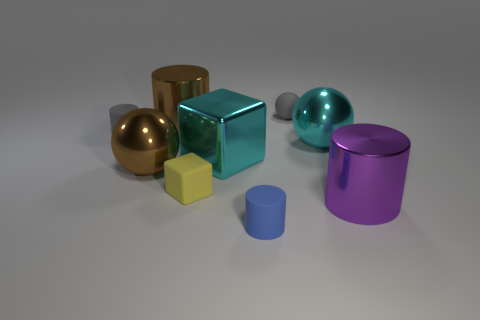Subtract all big metal spheres. How many spheres are left? 1 Add 1 red rubber things. How many objects exist? 10 Subtract all brown spheres. How many spheres are left? 2 Subtract all spheres. How many objects are left? 6 Subtract 1 cylinders. How many cylinders are left? 3 Subtract all purple cylinders. Subtract all blue spheres. How many cylinders are left? 3 Subtract all red cubes. How many gray balls are left? 1 Subtract all big cyan balls. Subtract all large brown metallic spheres. How many objects are left? 7 Add 6 brown balls. How many brown balls are left? 7 Add 3 gray cylinders. How many gray cylinders exist? 4 